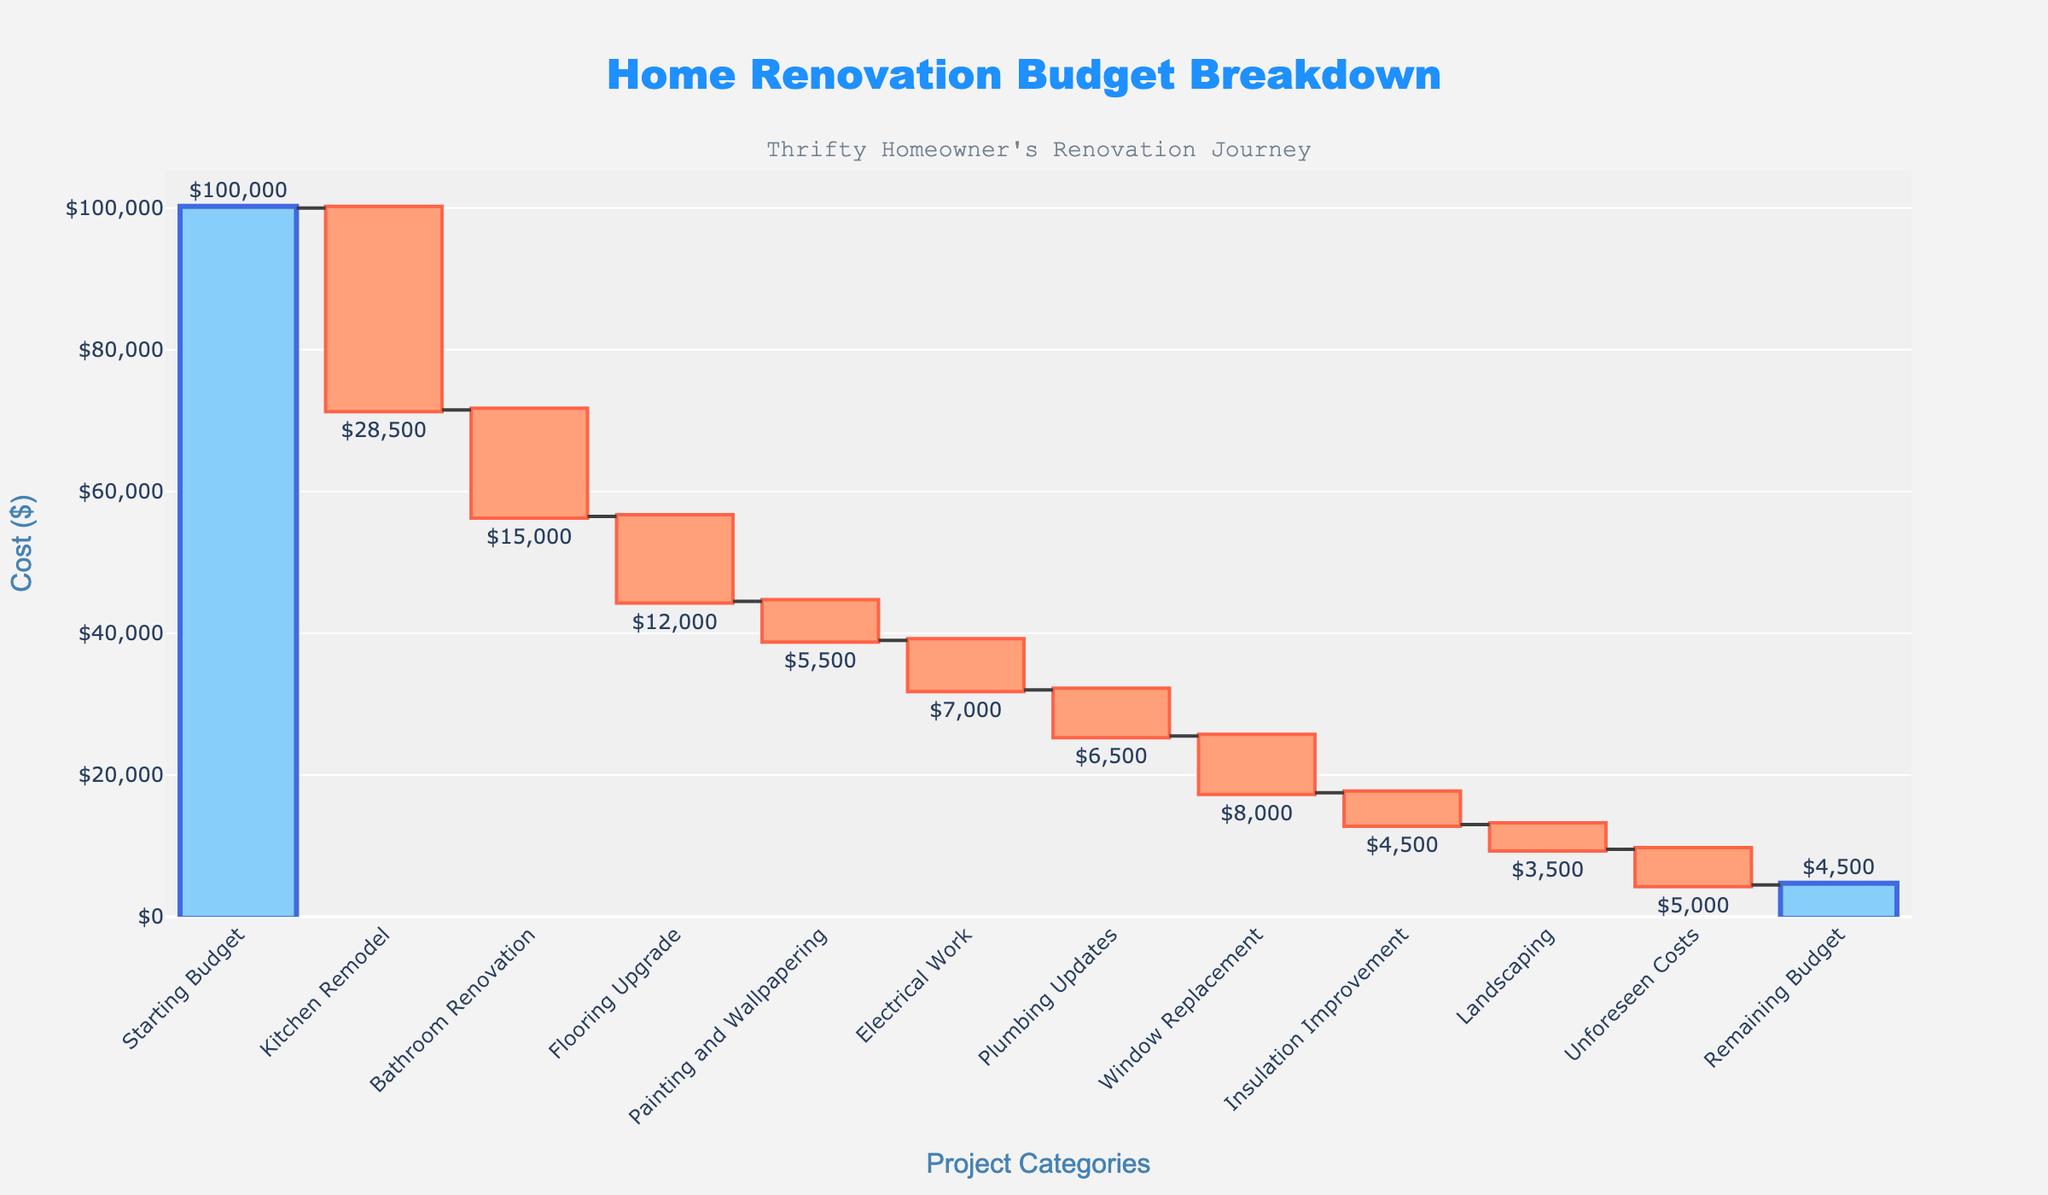What is the title of the chart? The title of the chart is usually displayed at the top of the figure in a larger font size. Here, it reads "Home Renovation Budget Breakdown".
Answer: Home Renovation Budget Breakdown How many project categories are detailed in the chart? Review all the unique labels on the x-axis which represent different project categories. There are 11 project categories listed.
Answer: 11 What is the total cost allocated for Kitchen Remodel? The "Kitchen Remodel" bar shows a value of $28,500 on the chart.
Answer: $28,500 Which project category resulted in the highest cost, and what is that amount? Comparing the heights of the negative bars, the "Kitchen Remodel" has the highest cost indicated by a value of $28,500.
Answer: Kitchen Remodel, $28,500 What is the remaining budget after all renovations? The last bar labeled "Remaining Budget" reflects the leftover amount, which is $4,500.
Answer: $4,500 Calculate the total cost spent on Flooring Upgrade, Painting and Wallpapering, and Electrical Work. Add the values for "Flooring Upgrade" ($12,000), "Painting and Wallpapering" ($5,500), and "Electrical Work" ($7,000): \( 12000 + 5500 + 7000 = 24500 \).
Answer: $24,500 Which project categories each cost less than $5,000? Identify the bars with values less than $5,000. These categories are "Insulation Improvement" ($4,500) and "Landscaping" ($3,500).
Answer: Insulation Improvement, Landscaping After the Bathroom Renovation, what was the budget remaining? Subtract the cost of the Bathroom Renovation ($15,000) from the remaining budget after the Kitchen Remodel: \( 100000 - 28500 - 15000 = 56500 \).
Answer: $56,500 Compare the cost of Plumbing Updates and Unforeseen Costs. Which one is higher and by how much? The cost of Plumbing Updates ($6,500) and Unforeseen Costs ($5,000), compare them: \( 6500 - 5000 = 1500 \). Plumbing Updates are higher by $1,500.
Answer: Plumbing Updates, $1,500 What is the total expenditure on renovation projects excluding the Unforeseen Costs? Add up all expenditures except for "Unforeseen Costs": \( 28500 + 15000 + 12000 + 5500 + 7000 + 6500 + 8000 + 4500 + 3500 = 91000 \).
Answer: $91,000 